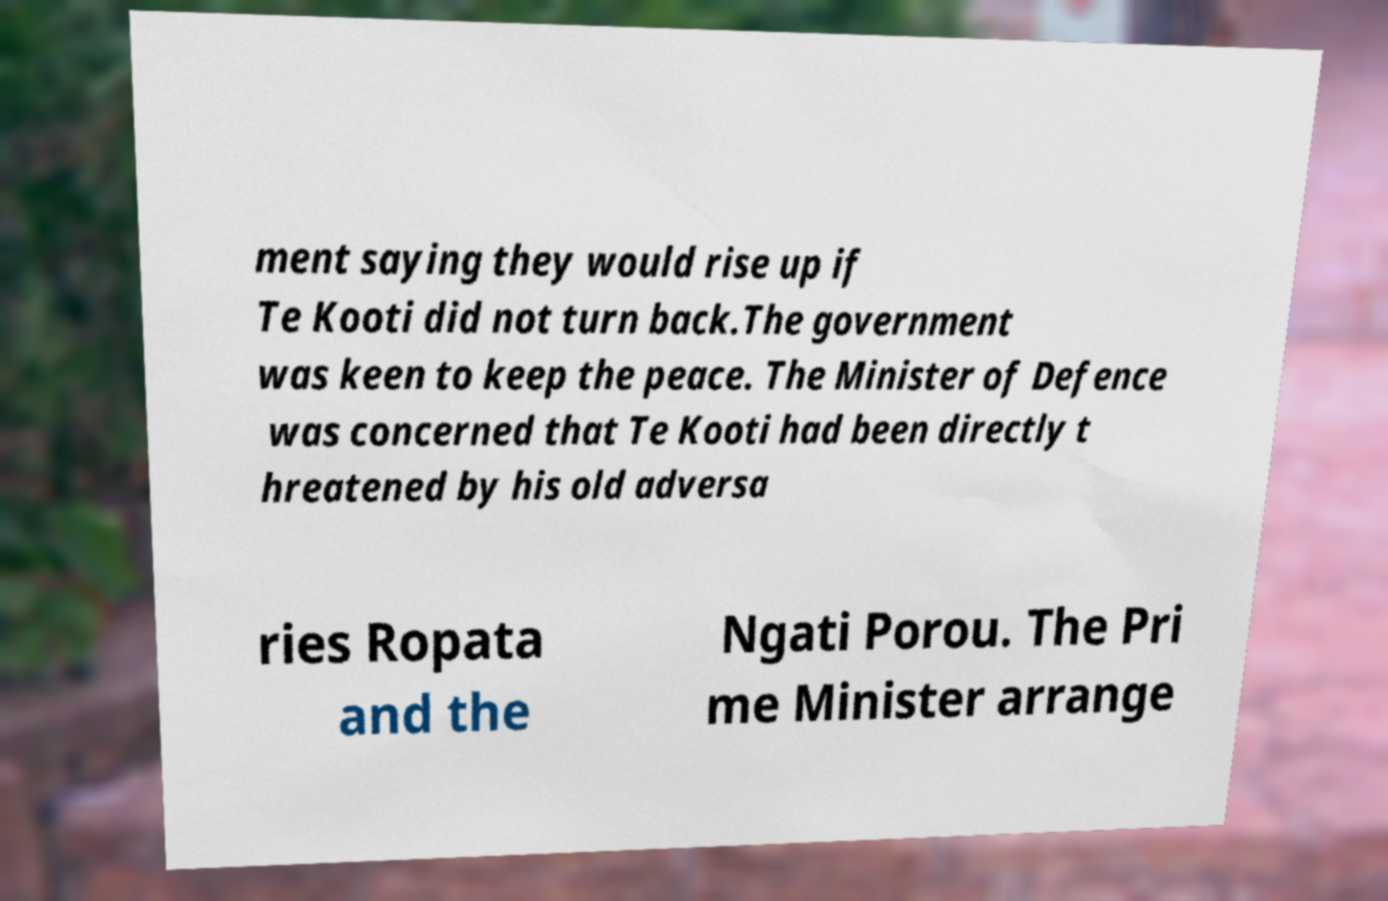Could you extract and type out the text from this image? ment saying they would rise up if Te Kooti did not turn back.The government was keen to keep the peace. The Minister of Defence was concerned that Te Kooti had been directly t hreatened by his old adversa ries Ropata and the Ngati Porou. The Pri me Minister arrange 